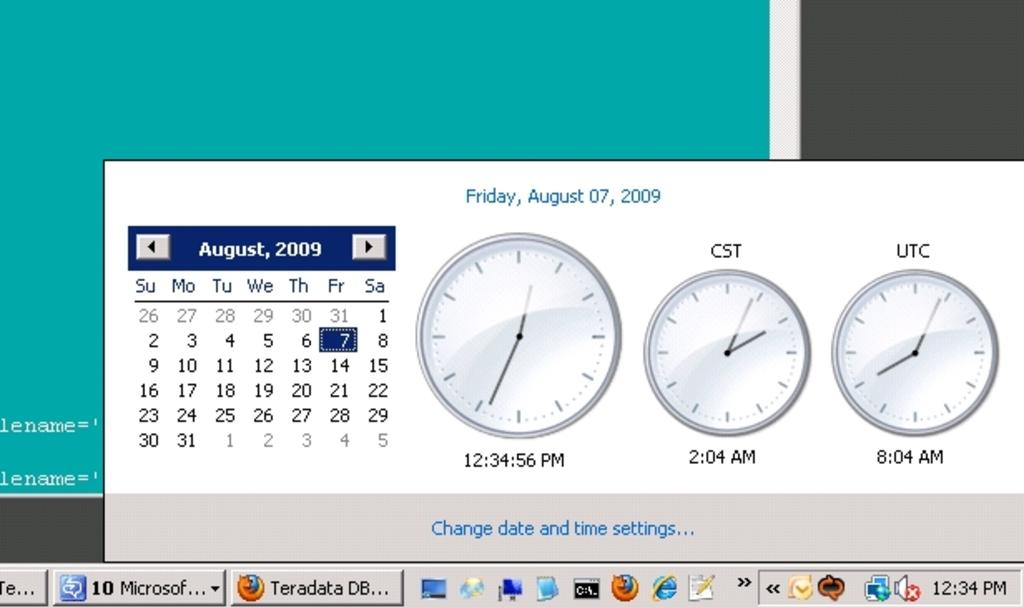Provide a one-sentence caption for the provided image. The calender and time setting tab on a computer screen with August 7th, Firday at 12:34:56 pm on it. 